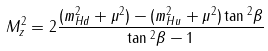<formula> <loc_0><loc_0><loc_500><loc_500>M _ { z } ^ { 2 } = 2 \frac { ( m _ { H d } ^ { 2 } + \mu ^ { 2 } ) - ( m _ { H u } ^ { 2 } + \mu ^ { 2 } ) \tan { ^ { 2 } \beta } } { \tan { ^ { 2 } \beta } - 1 }</formula> 